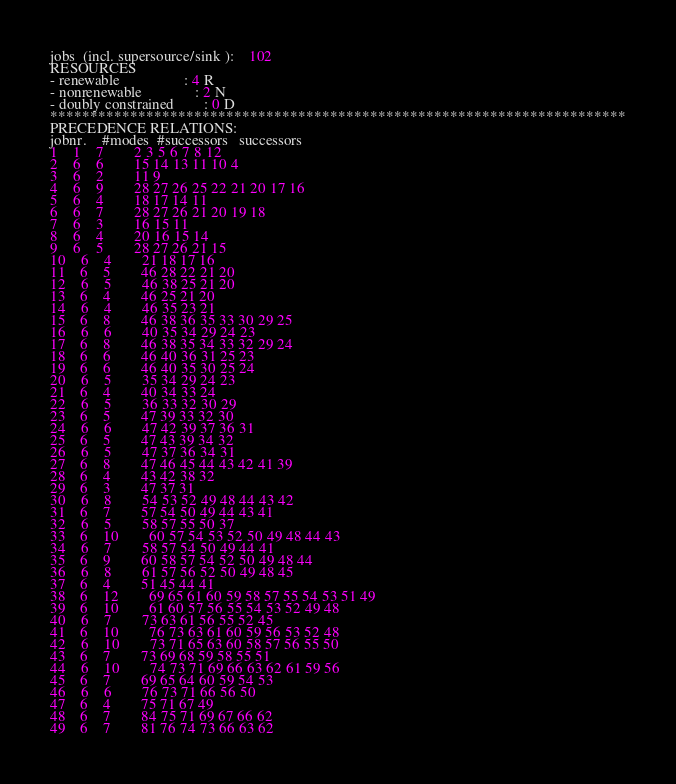<code> <loc_0><loc_0><loc_500><loc_500><_ObjectiveC_>jobs  (incl. supersource/sink ):	102
RESOURCES
- renewable                 : 4 R
- nonrenewable              : 2 N
- doubly constrained        : 0 D
************************************************************************
PRECEDENCE RELATIONS:
jobnr.    #modes  #successors   successors
1	1	7		2 3 5 6 7 8 12 
2	6	6		15 14 13 11 10 4 
3	6	2		11 9 
4	6	9		28 27 26 25 22 21 20 17 16 
5	6	4		18 17 14 11 
6	6	7		28 27 26 21 20 19 18 
7	6	3		16 15 11 
8	6	4		20 16 15 14 
9	6	5		28 27 26 21 15 
10	6	4		21 18 17 16 
11	6	5		46 28 22 21 20 
12	6	5		46 38 25 21 20 
13	6	4		46 25 21 20 
14	6	4		46 35 23 21 
15	6	8		46 38 36 35 33 30 29 25 
16	6	6		40 35 34 29 24 23 
17	6	8		46 38 35 34 33 32 29 24 
18	6	6		46 40 36 31 25 23 
19	6	6		46 40 35 30 25 24 
20	6	5		35 34 29 24 23 
21	6	4		40 34 33 24 
22	6	5		36 33 32 30 29 
23	6	5		47 39 33 32 30 
24	6	6		47 42 39 37 36 31 
25	6	5		47 43 39 34 32 
26	6	5		47 37 36 34 31 
27	6	8		47 46 45 44 43 42 41 39 
28	6	4		43 42 38 32 
29	6	3		47 37 31 
30	6	8		54 53 52 49 48 44 43 42 
31	6	7		57 54 50 49 44 43 41 
32	6	5		58 57 55 50 37 
33	6	10		60 57 54 53 52 50 49 48 44 43 
34	6	7		58 57 54 50 49 44 41 
35	6	9		60 58 57 54 52 50 49 48 44 
36	6	8		61 57 56 52 50 49 48 45 
37	6	4		51 45 44 41 
38	6	12		69 65 61 60 59 58 57 55 54 53 51 49 
39	6	10		61 60 57 56 55 54 53 52 49 48 
40	6	7		73 63 61 56 55 52 45 
41	6	10		76 73 63 61 60 59 56 53 52 48 
42	6	10		73 71 65 63 60 58 57 56 55 50 
43	6	7		73 69 68 59 58 55 51 
44	6	10		74 73 71 69 66 63 62 61 59 56 
45	6	7		69 65 64 60 59 54 53 
46	6	6		76 73 71 66 56 50 
47	6	4		75 71 67 49 
48	6	7		84 75 71 69 67 66 62 
49	6	7		81 76 74 73 66 63 62 </code> 